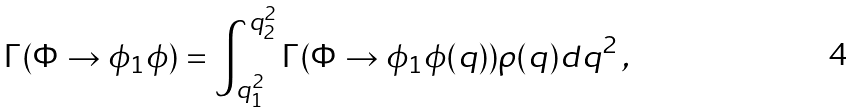<formula> <loc_0><loc_0><loc_500><loc_500>\Gamma ( \Phi \rightarrow \phi _ { 1 } \phi ) = \int _ { q ^ { 2 } _ { 1 } } ^ { q ^ { 2 } _ { 2 } } \Gamma ( \Phi \rightarrow \phi _ { 1 } \phi ( q ) ) \rho ( q ) d q ^ { 2 } \, ,</formula> 